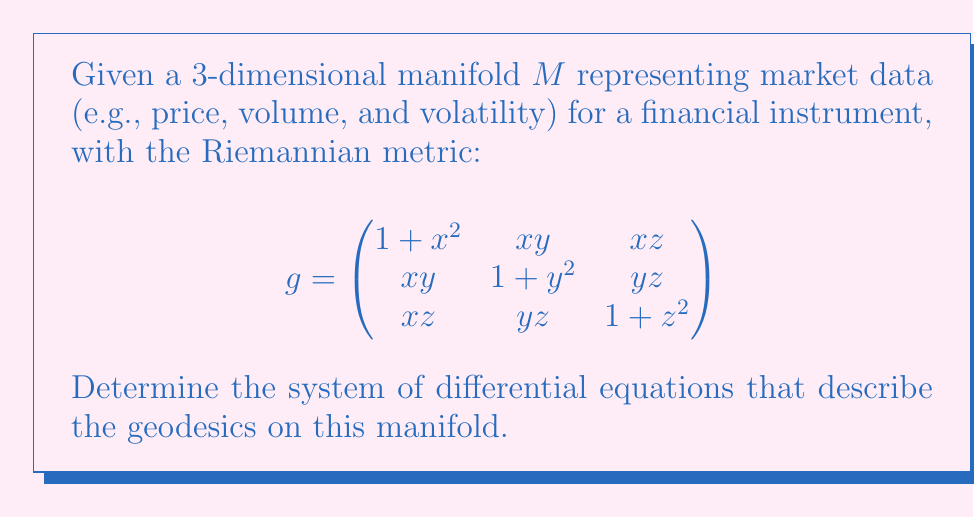Help me with this question. To find the geodesics on the manifold, we need to derive the Christoffel symbols and then use them to set up the geodesic equations. Let's proceed step-by-step:

1. First, we need to calculate the inverse metric $g^{ij}$. Due to the complexity of the matrix, we'll denote it as:

   $$g^{-1} = \begin{pmatrix}
   g^{11} & g^{12} & g^{13} \\
   g^{21} & g^{22} & g^{23} \\
   g^{31} & g^{32} & g^{33}
   \end{pmatrix}$$

2. Next, we calculate the Christoffel symbols using the formula:

   $$\Gamma^k_{ij} = \frac{1}{2}g^{kl}\left(\frac{\partial g_{il}}{\partial x^j} + \frac{\partial g_{jl}}{\partial x^i} - \frac{\partial g_{ij}}{\partial x^l}\right)$$

3. Due to the symmetry of the metric, many of the Christoffel symbols will be zero or equal to each other. The non-zero symbols are:

   $$\Gamma^1_{11} = \frac{x}{1+x^2}, \Gamma^1_{12} = \Gamma^1_{21} = -\frac{y}{1+x^2}, \Gamma^1_{13} = \Gamma^1_{31} = -\frac{z}{1+x^2}$$
   $$\Gamma^2_{12} = \Gamma^2_{21} = -\frac{x}{1+y^2}, \Gamma^2_{22} = \frac{y}{1+y^2}, \Gamma^2_{23} = \Gamma^2_{32} = -\frac{z}{1+y^2}$$
   $$\Gamma^3_{13} = \Gamma^3_{31} = -\frac{x}{1+z^2}, \Gamma^3_{23} = \Gamma^3_{32} = -\frac{y}{1+z^2}, \Gamma^3_{33} = \frac{z}{1+z^2}$$

4. The geodesic equations are given by:

   $$\frac{d^2x^k}{dt^2} + \Gamma^k_{ij}\frac{dx^i}{dt}\frac{dx^j}{dt} = 0$$

5. Substituting the Christoffel symbols, we get the system of differential equations:

   $$\frac{d^2x}{dt^2} + \frac{x}{1+x^2}\left(\frac{dx}{dt}\right)^2 - \frac{2y}{1+x^2}\frac{dx}{dt}\frac{dy}{dt} - \frac{2z}{1+x^2}\frac{dx}{dt}\frac{dz}{dt} = 0$$
   
   $$\frac{d^2y}{dt^2} - \frac{2x}{1+y^2}\frac{dx}{dt}\frac{dy}{dt} + \frac{y}{1+y^2}\left(\frac{dy}{dt}\right)^2 - \frac{2z}{1+y^2}\frac{dy}{dt}\frac{dz}{dt} = 0$$
   
   $$\frac{d^2z}{dt^2} - \frac{2x}{1+z^2}\frac{dx}{dt}\frac{dz}{dt} - \frac{2y}{1+z^2}\frac{dy}{dt}\frac{dz}{dt} + \frac{z}{1+z^2}\left(\frac{dz}{dt}\right)^2 = 0$$

These equations describe the geodesics on the given manifold.
Answer: $$\begin{cases}
\frac{d^2x}{dt^2} + \frac{x}{1+x^2}\left(\frac{dx}{dt}\right)^2 - \frac{2y}{1+x^2}\frac{dx}{dt}\frac{dy}{dt} - \frac{2z}{1+x^2}\frac{dx}{dt}\frac{dz}{dt} = 0 \\
\frac{d^2y}{dt^2} - \frac{2x}{1+y^2}\frac{dx}{dt}\frac{dy}{dt} + \frac{y}{1+y^2}\left(\frac{dy}{dt}\right)^2 - \frac{2z}{1+y^2}\frac{dy}{dt}\frac{dz}{dt} = 0 \\
\frac{d^2z}{dt^2} - \frac{2x}{1+z^2}\frac{dx}{dt}\frac{dz}{dt} - \frac{2y}{1+z^2}\frac{dy}{dt}\frac{dz}{dt} + \frac{z}{1+z^2}\left(\frac{dz}{dt}\right)^2 = 0
\end{cases}$$ 